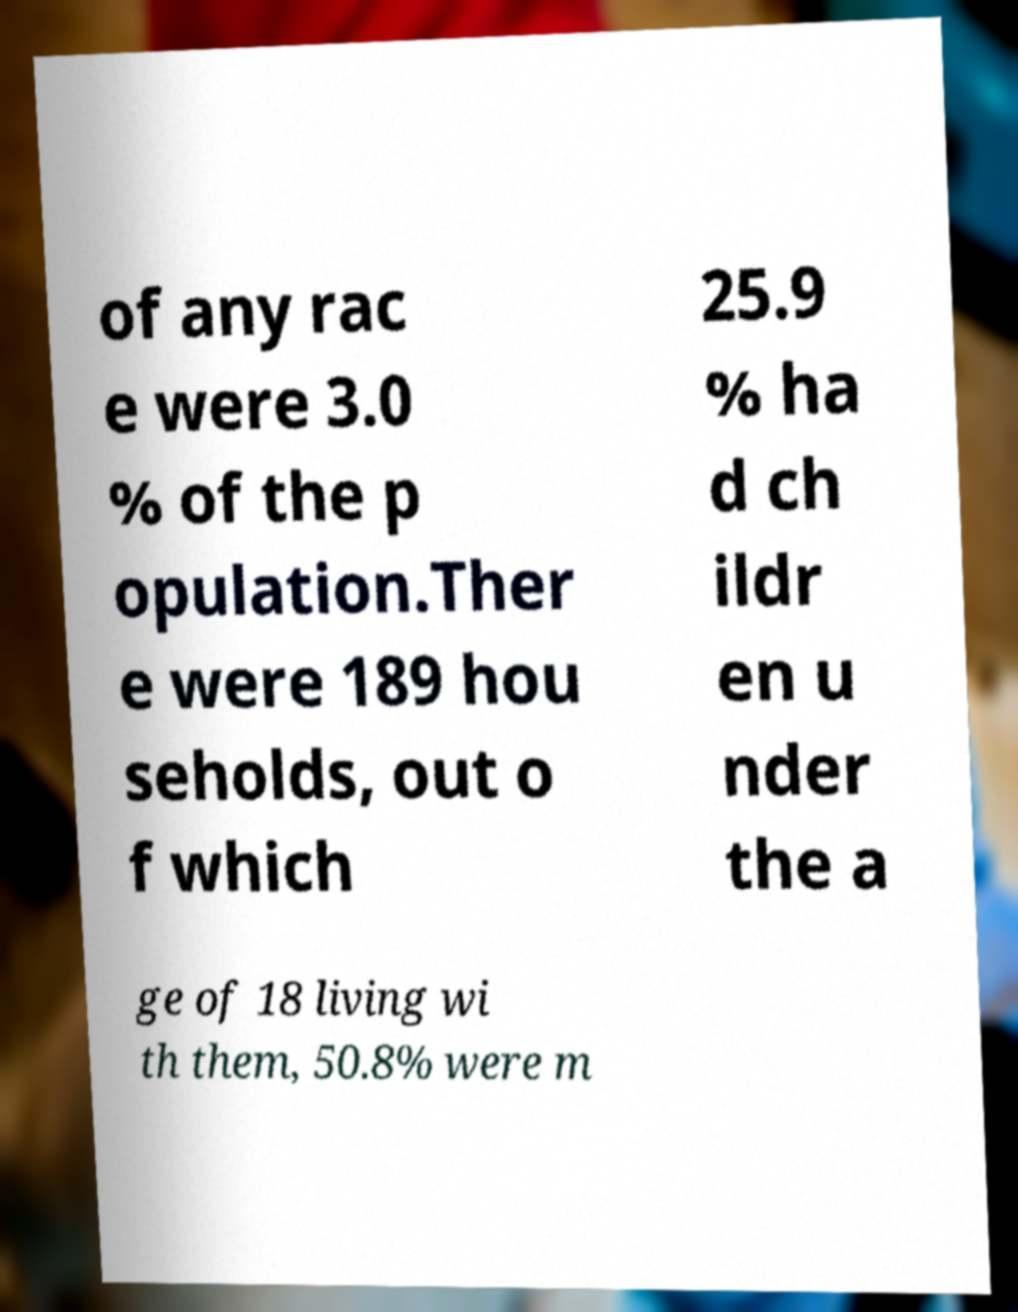Could you assist in decoding the text presented in this image and type it out clearly? of any rac e were 3.0 % of the p opulation.Ther e were 189 hou seholds, out o f which 25.9 % ha d ch ildr en u nder the a ge of 18 living wi th them, 50.8% were m 